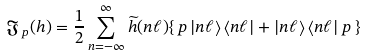<formula> <loc_0><loc_0><loc_500><loc_500>\mathfrak { J } _ { \, p } ( h ) = \frac { 1 } { 2 } \sum _ { n = - \infty } ^ { \infty } \widetilde { h } ( n \ell ) \{ \, p \left | n \ell \right \rangle \left \langle n \ell \right | + \left | n \ell \right \rangle \left \langle n \ell \right | p \, \}</formula> 